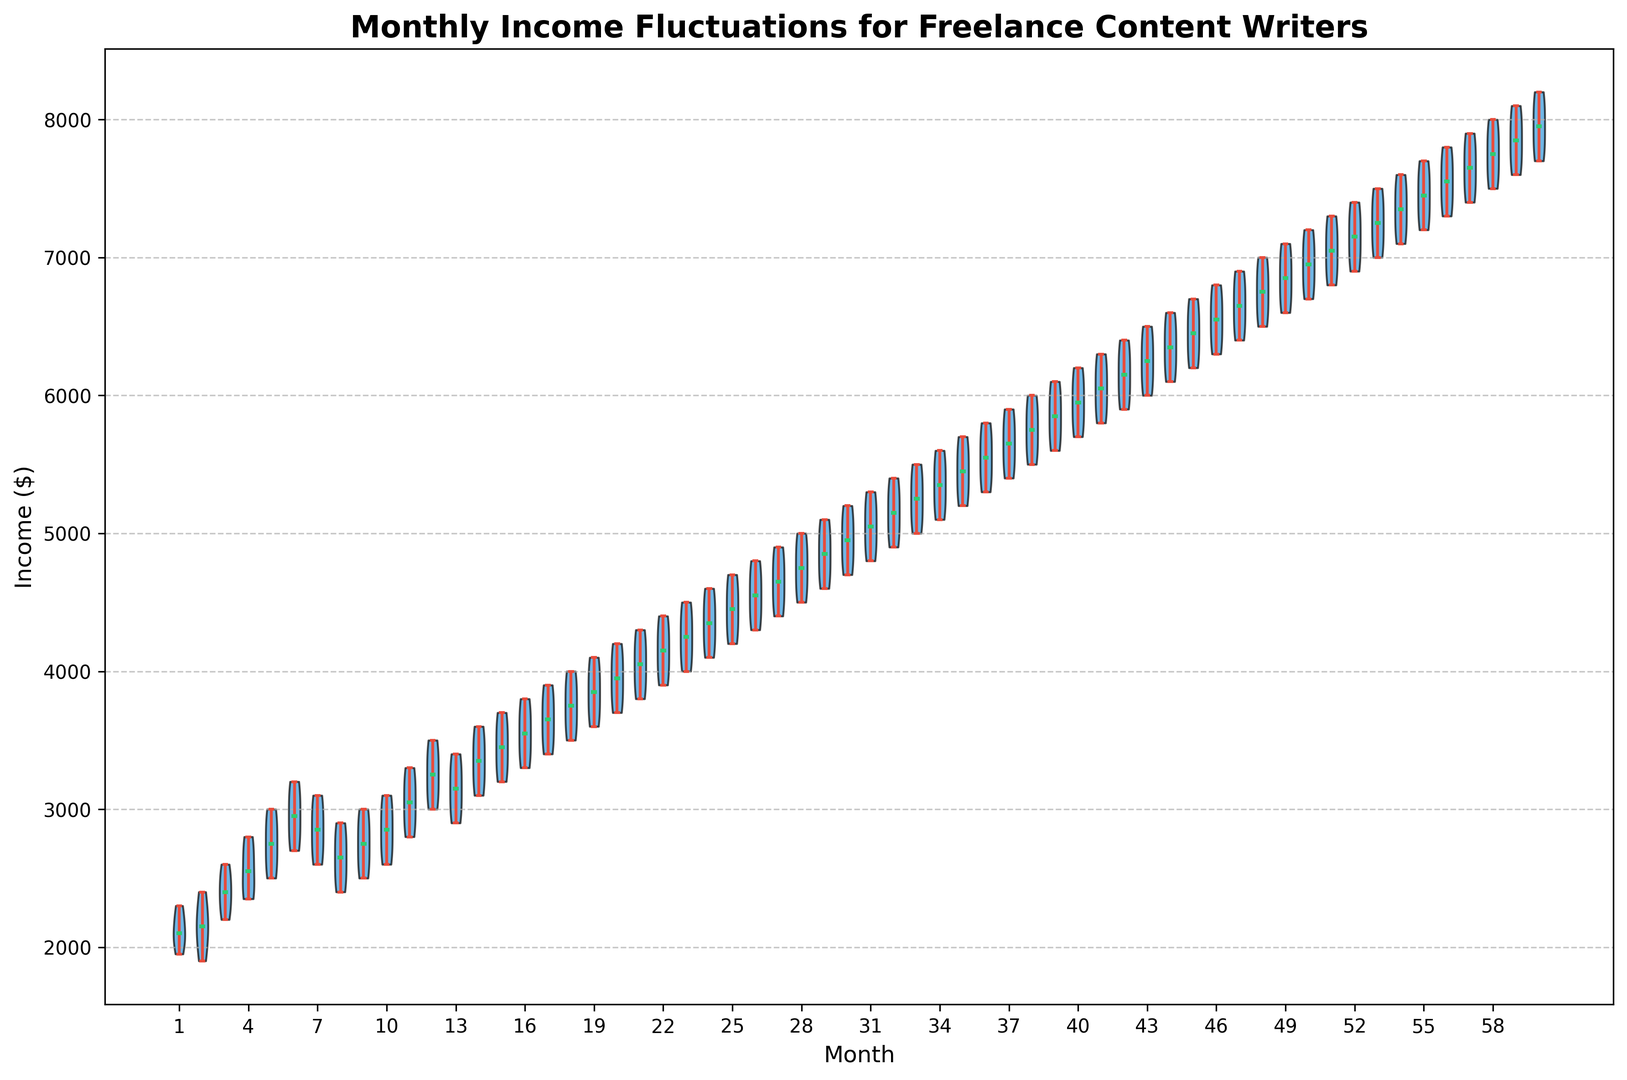Which month shows the highest average income? By looking at the violin plots, we can see that the highest point of the median line represents the month with the highest average income. The median line is green, and we find that month 60 has the highest median line.
Answer: Month 60 Is the median income higher in month 12 or month 24? To compare the medians, we look at the green median lines on the violin plots for both months. The median line in month 24 is higher than that of month 12, indicating a higher median income in month 24.
Answer: Month 24 Which month displays the widest range of income fluctuations? The range of income fluctuations can be seen by examining the spread of the violins. The month with the widest spread from top to bottom is month 60, indicating the widest range of income fluctuations.
Answer: Month 60 What can you say about the consistency of income in month 1 compared to month 12? Consistency can be inferred from the width of the violins. A wider violin denotes greater income variability. Month 1 has a relatively narrow violin, suggesting consistent income, whereas month 12 has a wider violin, suggesting more variable income.
Answer: Month 1 is more consistent Is there any month where the average income is below $3000? Average income is represented by the height of the median line on the violin plot. We look for any green median lines that fall below $3000. The first few months, such as month 1, have a median line below $3000.
Answer: Yes, in the initial months like month 1 Are there more months where the median income is around $5000 or $3000? Comparing the heights of the green median lines for each month, we count the occurrences where the median is closer to $5000 and $3000. There are more months with a median around $5000, especially in the latter half of the period.
Answer: Around $5000 Does month 30 have a higher or lower median income than month 20? We find the green median lines for both months and compare their heights. Month 30 has a higher median line than month 20.
Answer: Higher Between months 55 and 60, which has a greater income range? We compare the spread of the violins for these months. Month 60 has a slightly wider spread than month 55, indicating a greater income range.
Answer: Month 60 What can you infer about the income trend over the five-year period? Observing the overall shift in the median lines from month 1 to month 60, we can note a general upward trend in medians, indicating increasing income over the period.
Answer: Upward trend Are there any outlier months that deviate significantly from the general income trend? Outliers are identified by looking for months where the median line or the range within the violin is significantly different from neighboring months. For example, month 1 shows much lower income medians compared to the later months.
Answer: Month 1 